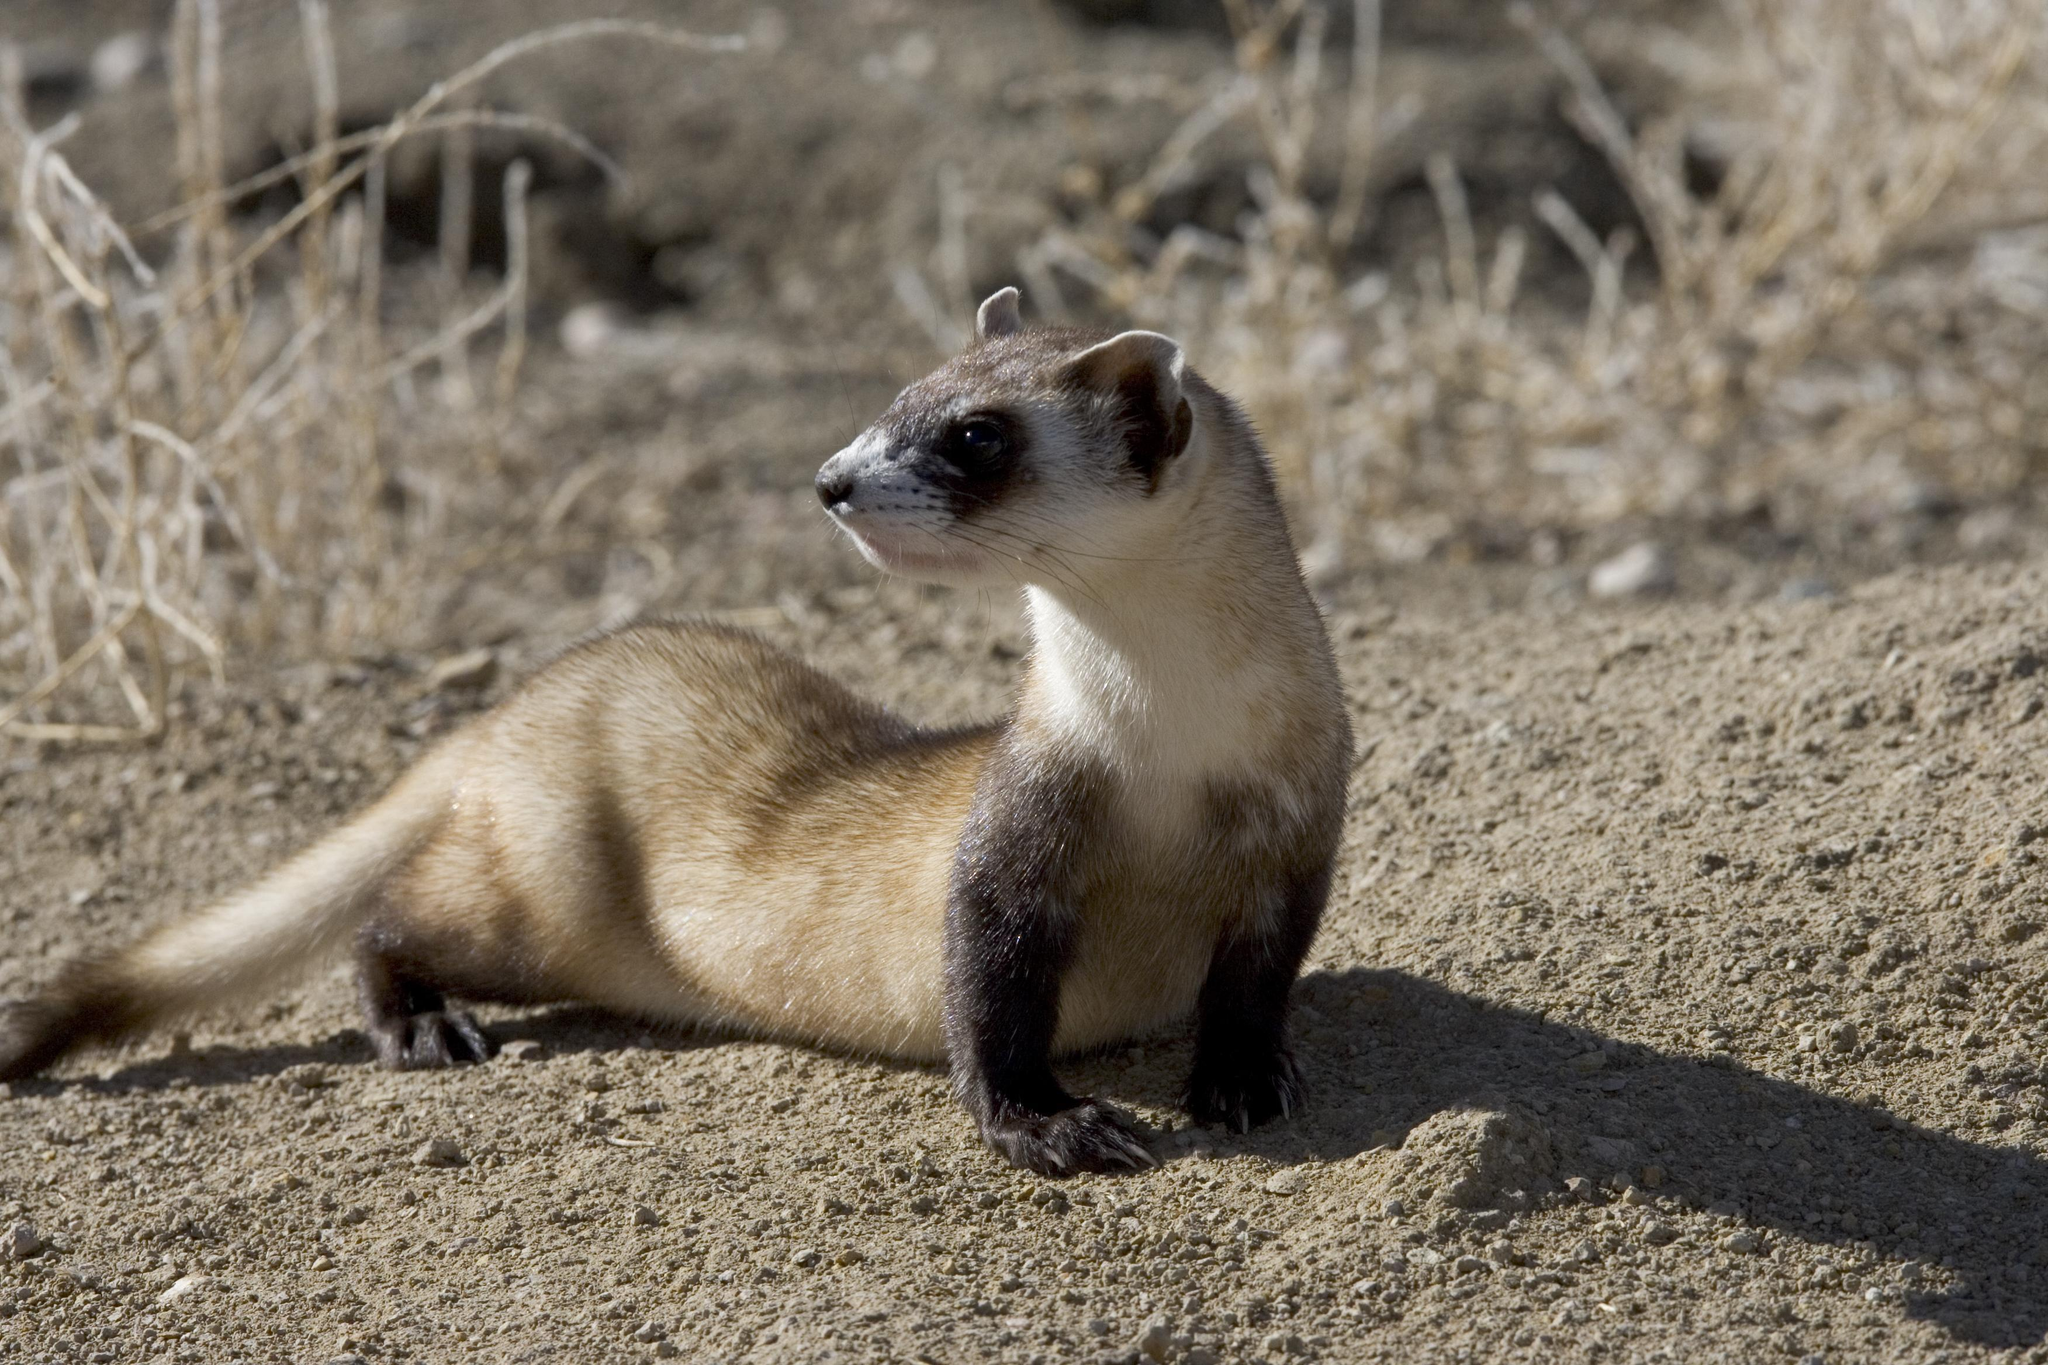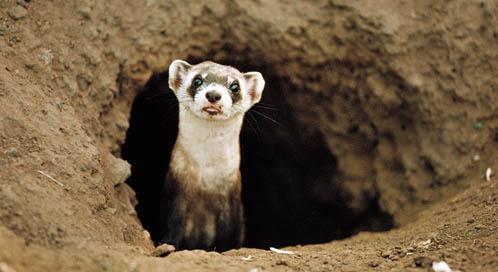The first image is the image on the left, the second image is the image on the right. Given the left and right images, does the statement "An animal's head and neck are visible just outside a hole." hold true? Answer yes or no. Yes. The first image is the image on the left, the second image is the image on the right. Evaluate the accuracy of this statement regarding the images: "One animal is in a hole, one animal is not, and there is not a third animal.". Is it true? Answer yes or no. Yes. 